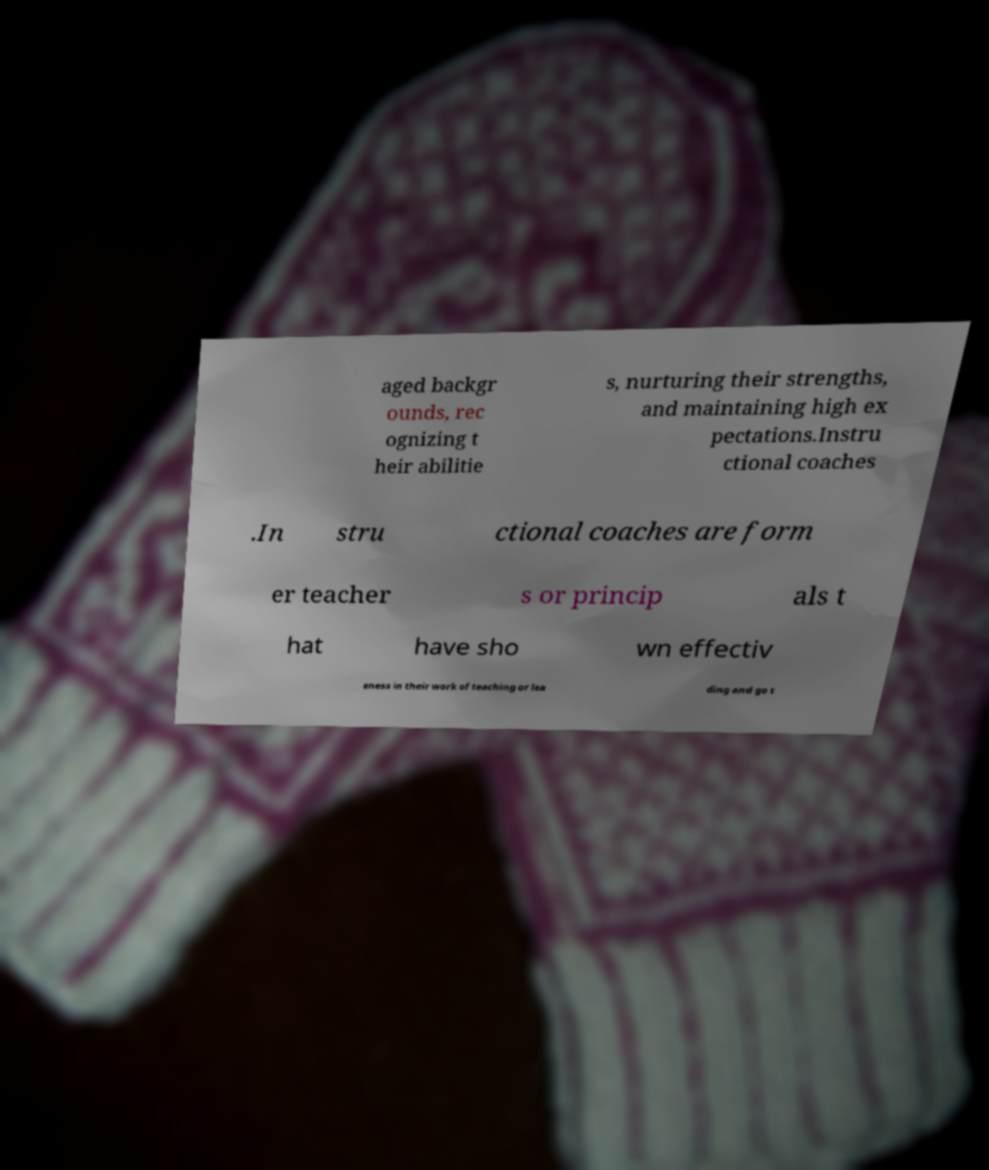Could you extract and type out the text from this image? aged backgr ounds, rec ognizing t heir abilitie s, nurturing their strengths, and maintaining high ex pectations.Instru ctional coaches .In stru ctional coaches are form er teacher s or princip als t hat have sho wn effectiv eness in their work of teaching or lea ding and go t 